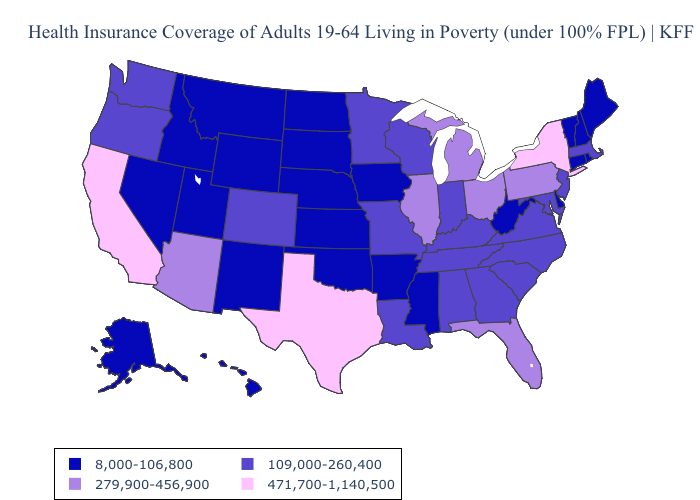Name the states that have a value in the range 279,900-456,900?
Quick response, please. Arizona, Florida, Illinois, Michigan, Ohio, Pennsylvania. Name the states that have a value in the range 279,900-456,900?
Be succinct. Arizona, Florida, Illinois, Michigan, Ohio, Pennsylvania. Name the states that have a value in the range 8,000-106,800?
Write a very short answer. Alaska, Arkansas, Connecticut, Delaware, Hawaii, Idaho, Iowa, Kansas, Maine, Mississippi, Montana, Nebraska, Nevada, New Hampshire, New Mexico, North Dakota, Oklahoma, Rhode Island, South Dakota, Utah, Vermont, West Virginia, Wyoming. Does Wisconsin have a lower value than Maryland?
Concise answer only. No. Does Wisconsin have the lowest value in the USA?
Quick response, please. No. Name the states that have a value in the range 8,000-106,800?
Concise answer only. Alaska, Arkansas, Connecticut, Delaware, Hawaii, Idaho, Iowa, Kansas, Maine, Mississippi, Montana, Nebraska, Nevada, New Hampshire, New Mexico, North Dakota, Oklahoma, Rhode Island, South Dakota, Utah, Vermont, West Virginia, Wyoming. Among the states that border Nevada , which have the highest value?
Concise answer only. California. Which states have the lowest value in the USA?
Keep it brief. Alaska, Arkansas, Connecticut, Delaware, Hawaii, Idaho, Iowa, Kansas, Maine, Mississippi, Montana, Nebraska, Nevada, New Hampshire, New Mexico, North Dakota, Oklahoma, Rhode Island, South Dakota, Utah, Vermont, West Virginia, Wyoming. What is the highest value in states that border New York?
Concise answer only. 279,900-456,900. Among the states that border Missouri , does Oklahoma have the highest value?
Concise answer only. No. What is the highest value in the USA?
Short answer required. 471,700-1,140,500. Among the states that border Washington , does Oregon have the lowest value?
Quick response, please. No. Does the map have missing data?
Concise answer only. No. Among the states that border Montana , which have the highest value?
Write a very short answer. Idaho, North Dakota, South Dakota, Wyoming. What is the value of North Carolina?
Write a very short answer. 109,000-260,400. 